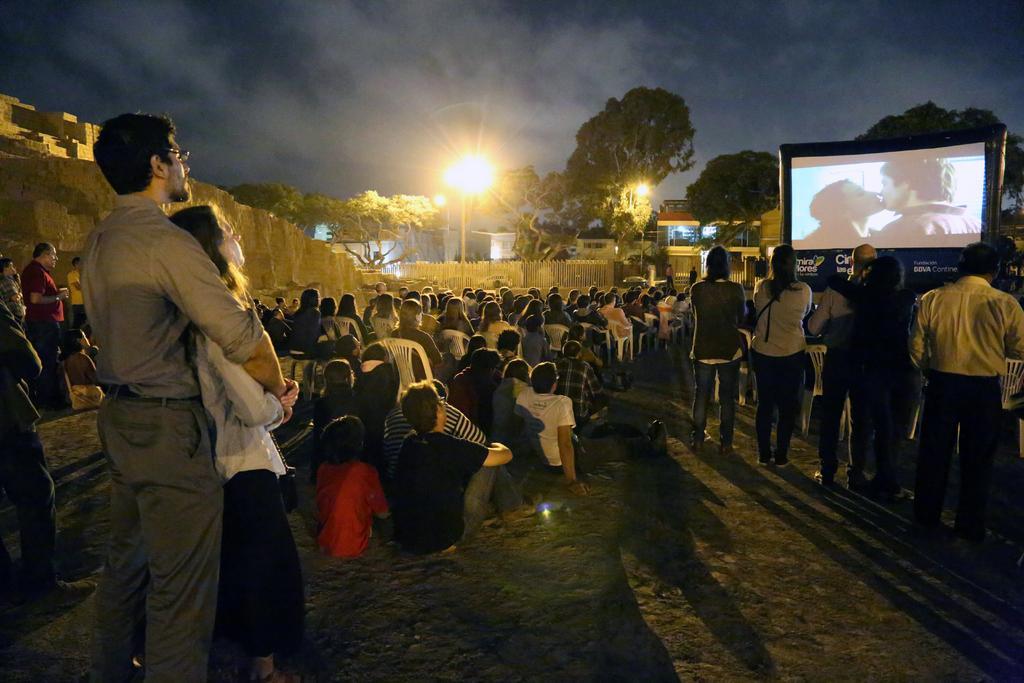Describe this image in one or two sentences. In the foreground, I can see a group of people are sitting on the chairs and a few of them are standing on grass in front of a screen. In the background, I can see a fence, a wall, trees, lights, buildings and the sky. This image is taken, maybe during the night. 